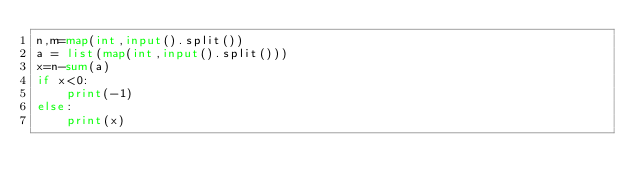<code> <loc_0><loc_0><loc_500><loc_500><_Python_>n,m=map(int,input().split())
a = list(map(int,input().split()))
x=n-sum(a)
if x<0:
    print(-1)
else:
    print(x)</code> 